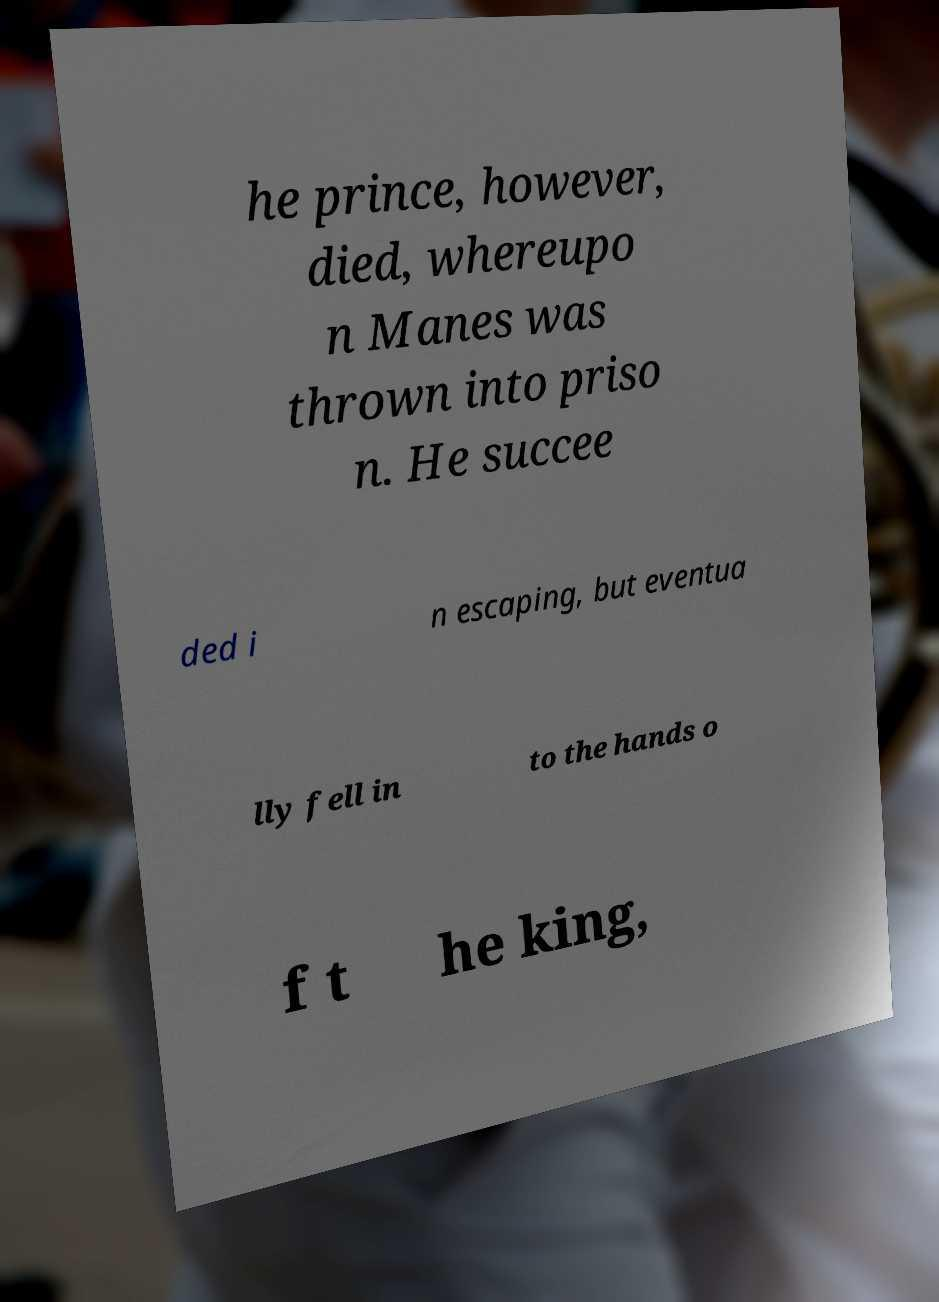Could you assist in decoding the text presented in this image and type it out clearly? he prince, however, died, whereupo n Manes was thrown into priso n. He succee ded i n escaping, but eventua lly fell in to the hands o f t he king, 